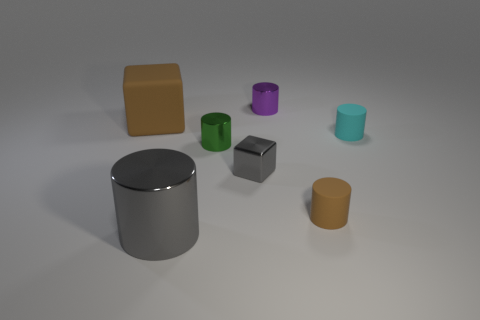Subtract 1 cylinders. How many cylinders are left? 4 Subtract all gray cylinders. How many cylinders are left? 4 Subtract all tiny cyan matte cylinders. How many cylinders are left? 4 Subtract all red cylinders. Subtract all gray cubes. How many cylinders are left? 5 Add 2 big yellow shiny cubes. How many objects exist? 9 Subtract all cylinders. How many objects are left? 2 Subtract 0 blue cylinders. How many objects are left? 7 Subtract all small purple rubber blocks. Subtract all purple cylinders. How many objects are left? 6 Add 1 small green objects. How many small green objects are left? 2 Add 5 big cylinders. How many big cylinders exist? 6 